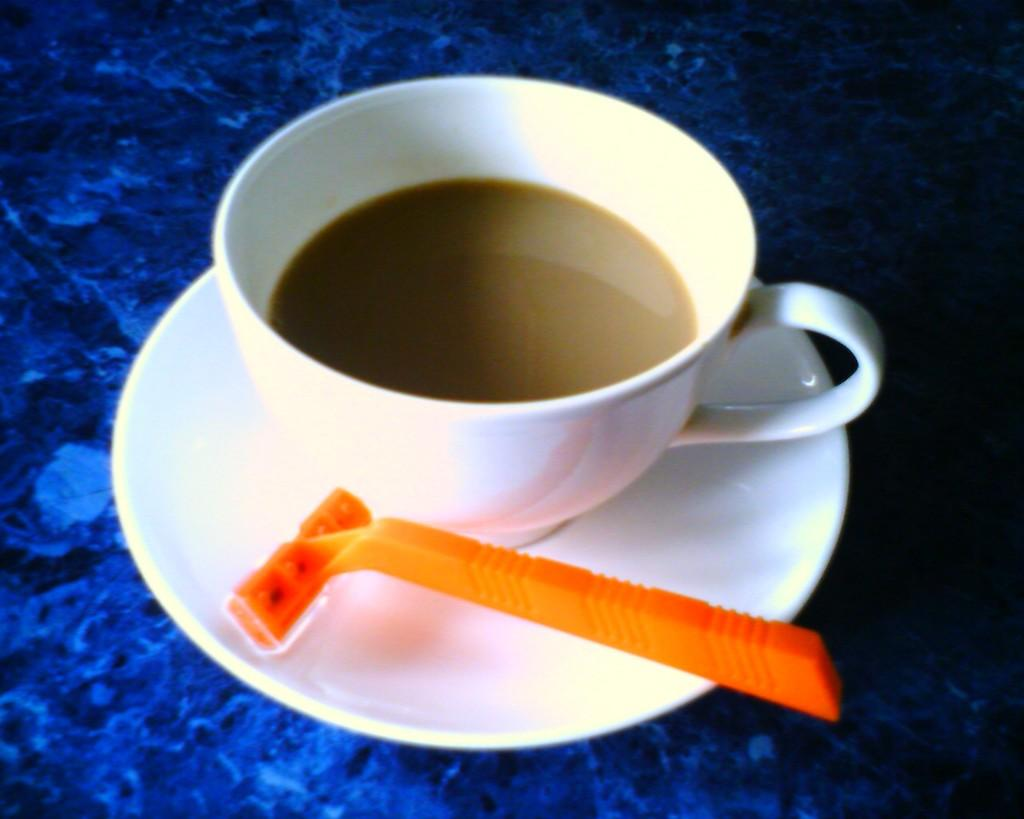What is in the center of the image? There is a cup with a saucer in the center of the image. What is inside the cup? The cup is filled with a drink. What type of object is the racer in the image? The racer is a toy or model car. Where are the cup and saucer placed? The cup and saucer are placed on a table. How many grandmothers are present in the image? There is no grandmother present in the image. Can you tell me the name of the friend who is holding the cup in the image? There is no friend holding the cup in the image; the cup and saucer are placed on a table. 